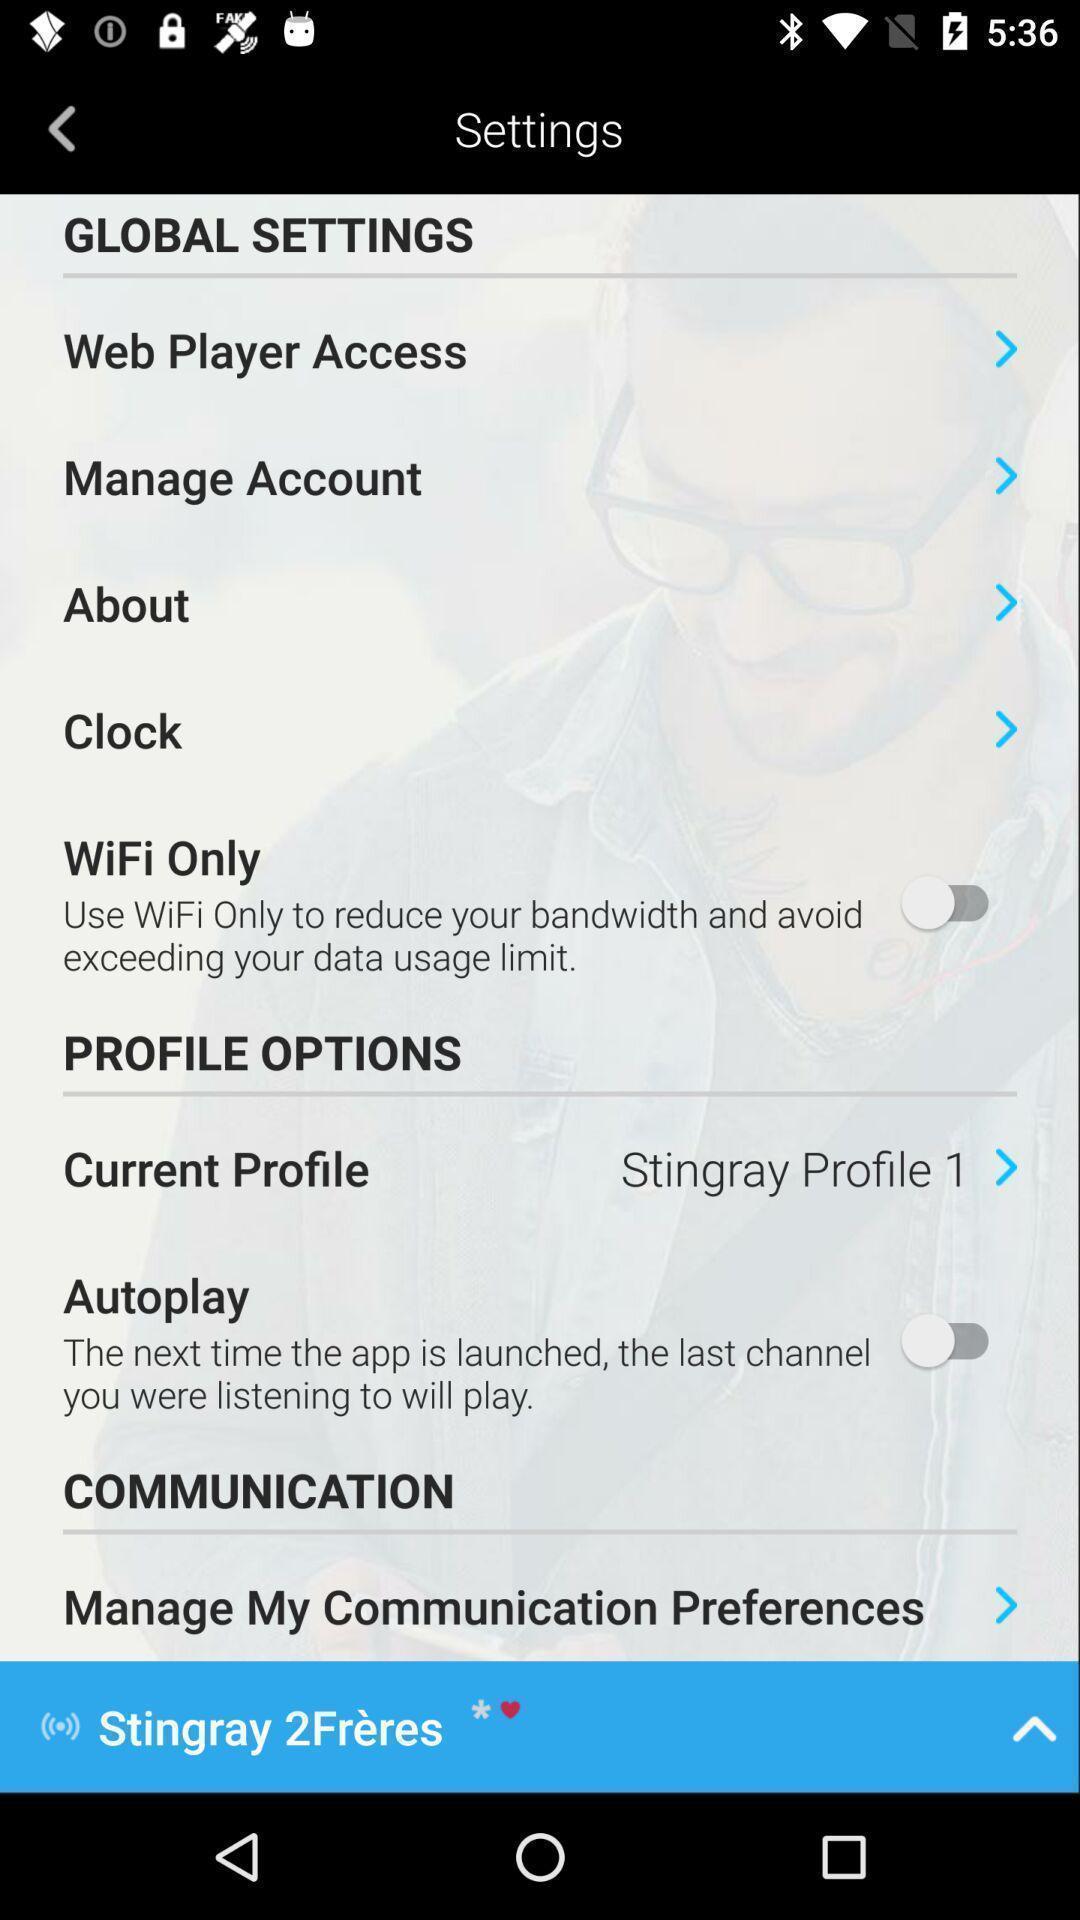Explain the elements present in this screenshot. Page showing different setting options. 